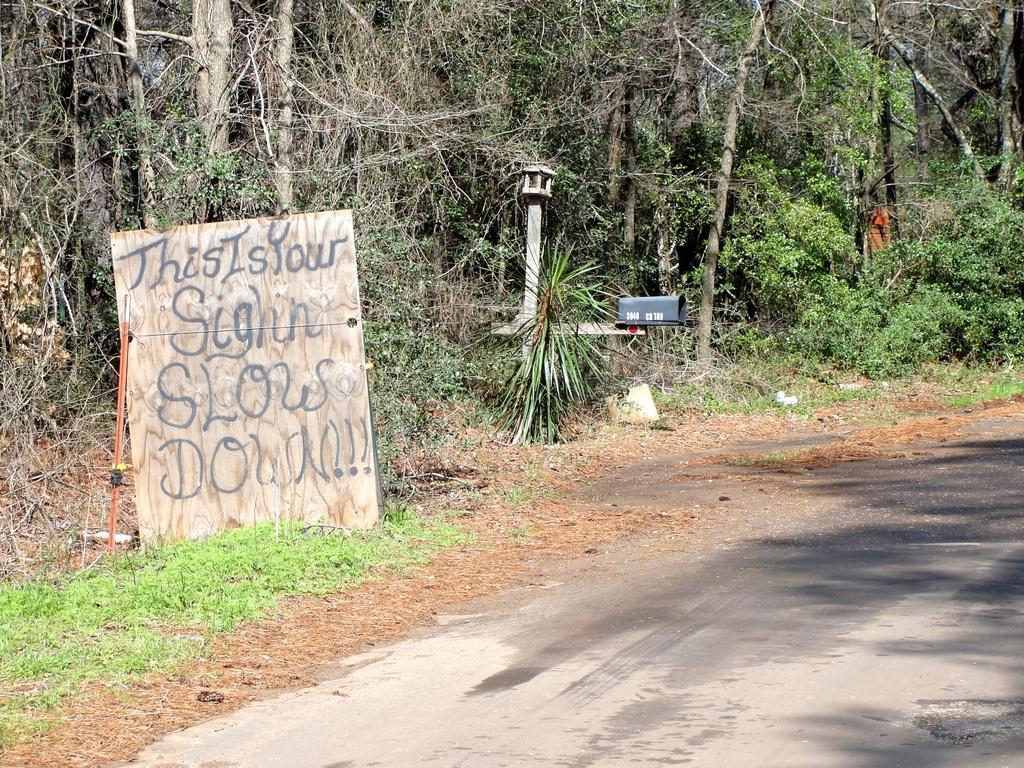Describe this image in one or two sentences. In this image, we can see trees, plants, poles, some boxes, board, stick, grass. At the bottom, we can see a road. Here we can see a person is standing. 